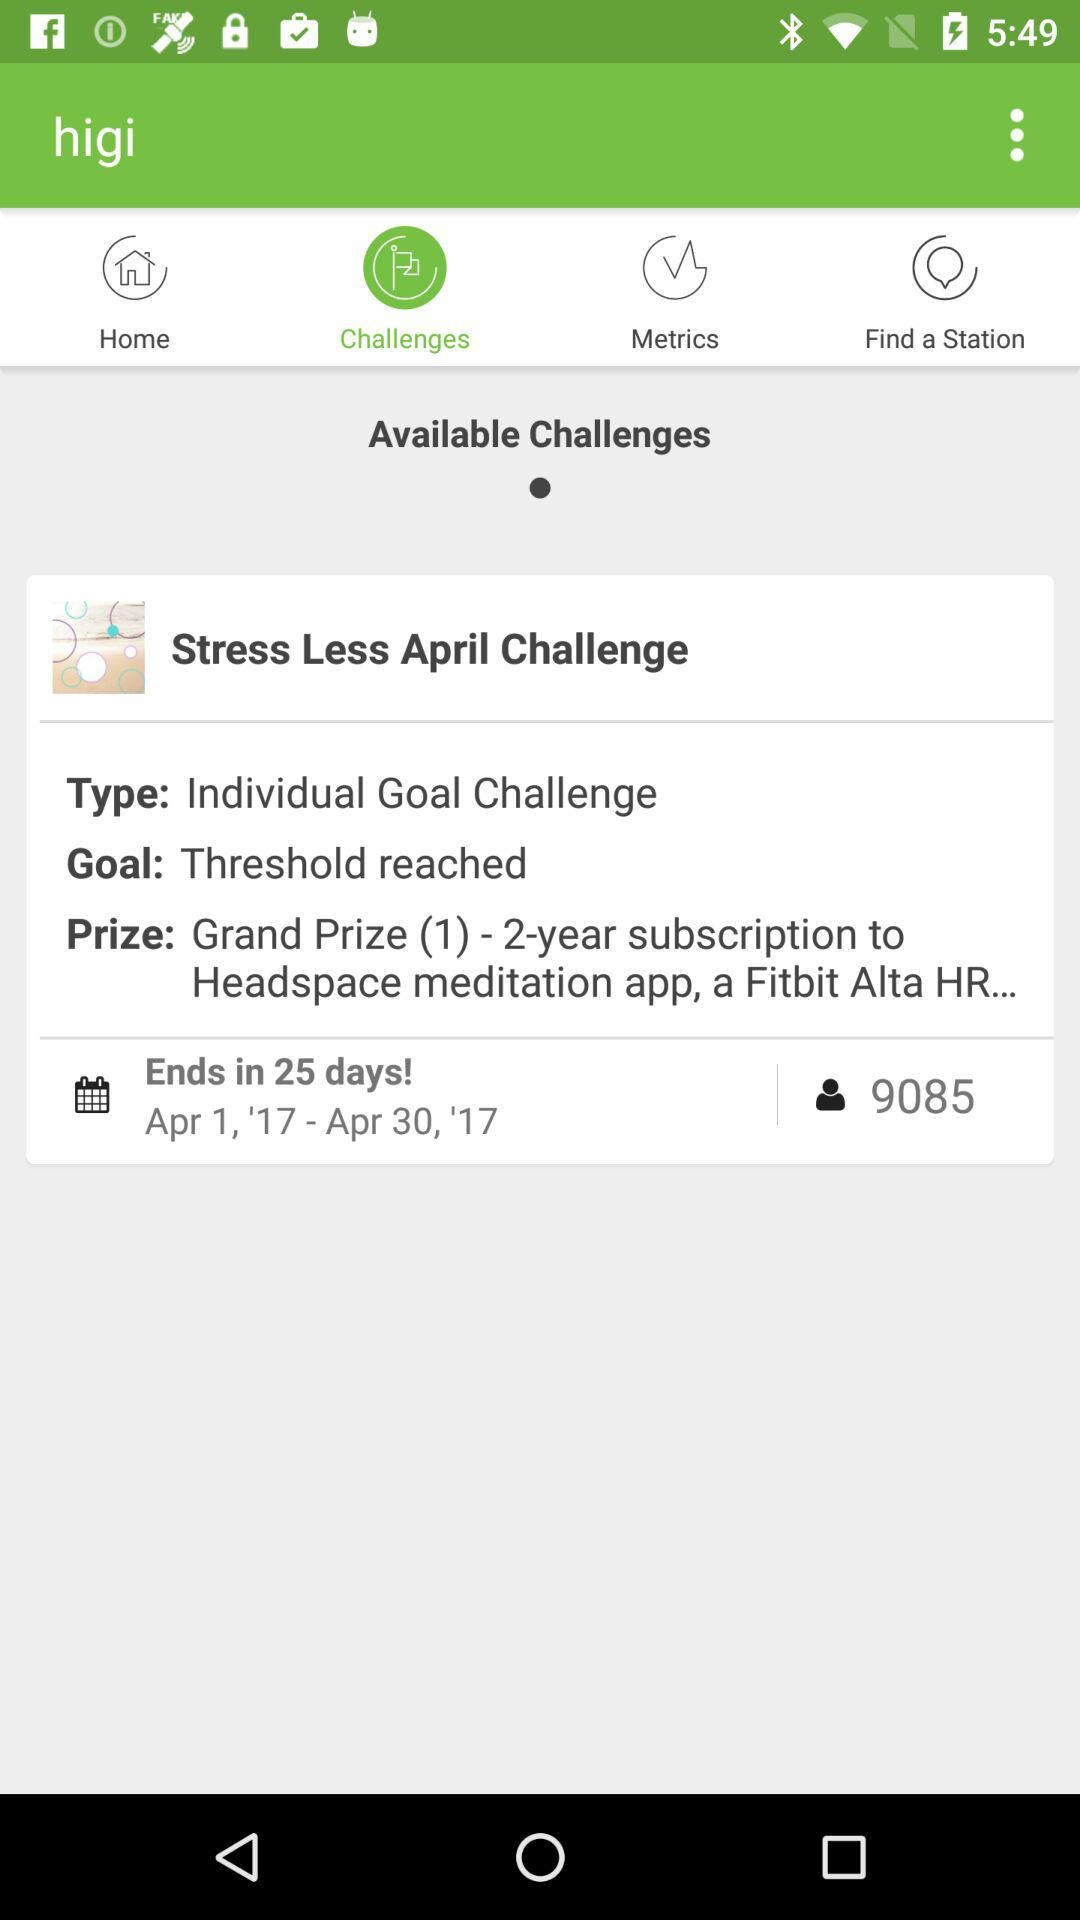What is the name of the available challenge? The name of the available challenge is "Stress Less April Challenge". 